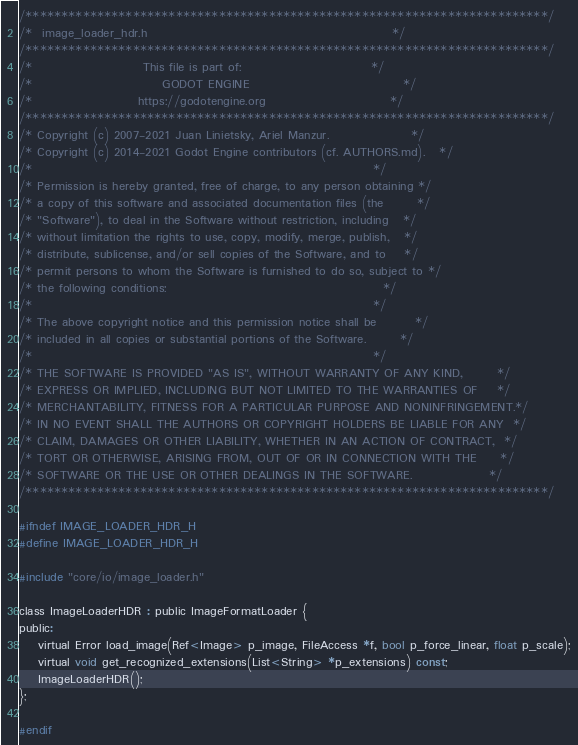Convert code to text. <code><loc_0><loc_0><loc_500><loc_500><_C_>/*************************************************************************/
/*  image_loader_hdr.h                                                   */
/*************************************************************************/
/*                       This file is part of:                           */
/*                           GODOT ENGINE                                */
/*                      https://godotengine.org                          */
/*************************************************************************/
/* Copyright (c) 2007-2021 Juan Linietsky, Ariel Manzur.                 */
/* Copyright (c) 2014-2021 Godot Engine contributors (cf. AUTHORS.md).   */
/*                                                                       */
/* Permission is hereby granted, free of charge, to any person obtaining */
/* a copy of this software and associated documentation files (the       */
/* "Software"), to deal in the Software without restriction, including   */
/* without limitation the rights to use, copy, modify, merge, publish,   */
/* distribute, sublicense, and/or sell copies of the Software, and to    */
/* permit persons to whom the Software is furnished to do so, subject to */
/* the following conditions:                                             */
/*                                                                       */
/* The above copyright notice and this permission notice shall be        */
/* included in all copies or substantial portions of the Software.       */
/*                                                                       */
/* THE SOFTWARE IS PROVIDED "AS IS", WITHOUT WARRANTY OF ANY KIND,       */
/* EXPRESS OR IMPLIED, INCLUDING BUT NOT LIMITED TO THE WARRANTIES OF    */
/* MERCHANTABILITY, FITNESS FOR A PARTICULAR PURPOSE AND NONINFRINGEMENT.*/
/* IN NO EVENT SHALL THE AUTHORS OR COPYRIGHT HOLDERS BE LIABLE FOR ANY  */
/* CLAIM, DAMAGES OR OTHER LIABILITY, WHETHER IN AN ACTION OF CONTRACT,  */
/* TORT OR OTHERWISE, ARISING FROM, OUT OF OR IN CONNECTION WITH THE     */
/* SOFTWARE OR THE USE OR OTHER DEALINGS IN THE SOFTWARE.                */
/*************************************************************************/

#ifndef IMAGE_LOADER_HDR_H
#define IMAGE_LOADER_HDR_H

#include "core/io/image_loader.h"

class ImageLoaderHDR : public ImageFormatLoader {
public:
	virtual Error load_image(Ref<Image> p_image, FileAccess *f, bool p_force_linear, float p_scale);
	virtual void get_recognized_extensions(List<String> *p_extensions) const;
	ImageLoaderHDR();
};

#endif
</code> 